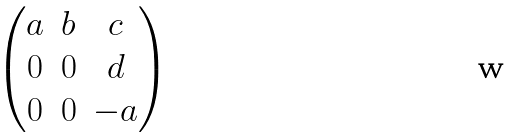<formula> <loc_0><loc_0><loc_500><loc_500>\begin{pmatrix} a & b & c \\ 0 & 0 & d \\ 0 & 0 & - a \\ \end{pmatrix}</formula> 